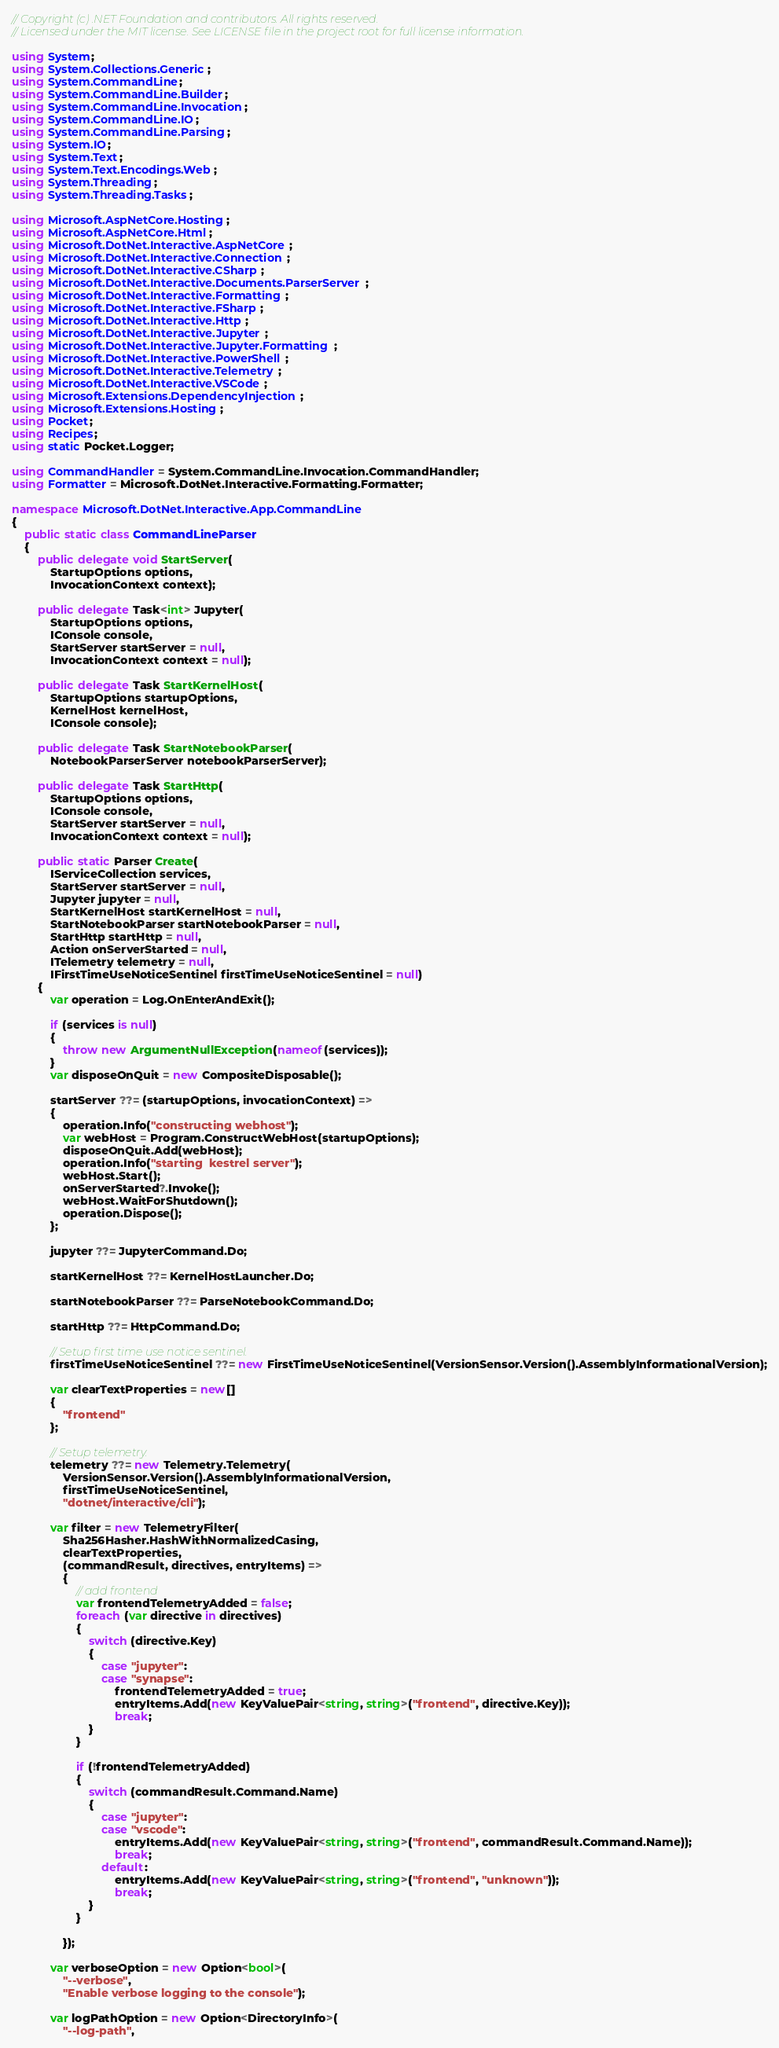Convert code to text. <code><loc_0><loc_0><loc_500><loc_500><_C#_>// Copyright (c) .NET Foundation and contributors. All rights reserved.
// Licensed under the MIT license. See LICENSE file in the project root for full license information.

using System;
using System.Collections.Generic;
using System.CommandLine;
using System.CommandLine.Builder;
using System.CommandLine.Invocation;
using System.CommandLine.IO;
using System.CommandLine.Parsing;
using System.IO;
using System.Text;
using System.Text.Encodings.Web;
using System.Threading;
using System.Threading.Tasks;

using Microsoft.AspNetCore.Hosting;
using Microsoft.AspNetCore.Html;
using Microsoft.DotNet.Interactive.AspNetCore;
using Microsoft.DotNet.Interactive.Connection;
using Microsoft.DotNet.Interactive.CSharp;
using Microsoft.DotNet.Interactive.Documents.ParserServer;
using Microsoft.DotNet.Interactive.Formatting;
using Microsoft.DotNet.Interactive.FSharp;
using Microsoft.DotNet.Interactive.Http;
using Microsoft.DotNet.Interactive.Jupyter;
using Microsoft.DotNet.Interactive.Jupyter.Formatting;
using Microsoft.DotNet.Interactive.PowerShell;
using Microsoft.DotNet.Interactive.Telemetry;
using Microsoft.DotNet.Interactive.VSCode;
using Microsoft.Extensions.DependencyInjection;
using Microsoft.Extensions.Hosting;
using Pocket;
using Recipes;
using static Pocket.Logger;

using CommandHandler = System.CommandLine.Invocation.CommandHandler;
using Formatter = Microsoft.DotNet.Interactive.Formatting.Formatter;

namespace Microsoft.DotNet.Interactive.App.CommandLine
{
    public static class CommandLineParser
    {
        public delegate void StartServer(
            StartupOptions options,
            InvocationContext context);

        public delegate Task<int> Jupyter(
            StartupOptions options,
            IConsole console,
            StartServer startServer = null,
            InvocationContext context = null);

        public delegate Task StartKernelHost(
            StartupOptions startupOptions,
            KernelHost kernelHost,
            IConsole console);

        public delegate Task StartNotebookParser(
            NotebookParserServer notebookParserServer);

        public delegate Task StartHttp(
            StartupOptions options,
            IConsole console,
            StartServer startServer = null,
            InvocationContext context = null);

        public static Parser Create(
            IServiceCollection services,
            StartServer startServer = null,
            Jupyter jupyter = null,
            StartKernelHost startKernelHost = null,
            StartNotebookParser startNotebookParser = null,
            StartHttp startHttp = null,
            Action onServerStarted = null,
            ITelemetry telemetry = null,
            IFirstTimeUseNoticeSentinel firstTimeUseNoticeSentinel = null)
        {
            var operation = Log.OnEnterAndExit();

            if (services is null)
            {
                throw new ArgumentNullException(nameof(services));
            }
            var disposeOnQuit = new CompositeDisposable();

            startServer ??= (startupOptions, invocationContext) =>
            {
                operation.Info("constructing webhost");
                var webHost = Program.ConstructWebHost(startupOptions);
                disposeOnQuit.Add(webHost);
                operation.Info("starting  kestrel server");
                webHost.Start();
                onServerStarted?.Invoke();
                webHost.WaitForShutdown();
                operation.Dispose();
            };

            jupyter ??= JupyterCommand.Do;

            startKernelHost ??= KernelHostLauncher.Do;
            
            startNotebookParser ??= ParseNotebookCommand.Do;

            startHttp ??= HttpCommand.Do;

            // Setup first time use notice sentinel.
            firstTimeUseNoticeSentinel ??= new FirstTimeUseNoticeSentinel(VersionSensor.Version().AssemblyInformationalVersion);

            var clearTextProperties = new[]
            {
                "frontend"
            };

            // Setup telemetry.
            telemetry ??= new Telemetry.Telemetry(
                VersionSensor.Version().AssemblyInformationalVersion,
                firstTimeUseNoticeSentinel,
                "dotnet/interactive/cli");

            var filter = new TelemetryFilter(
                Sha256Hasher.HashWithNormalizedCasing,
                clearTextProperties,
                (commandResult, directives, entryItems) =>
                {
                    // add frontend
                    var frontendTelemetryAdded = false;
                    foreach (var directive in directives)
                    {
                        switch (directive.Key)
                        {
                            case "jupyter":
                            case "synapse":
                                frontendTelemetryAdded = true;
                                entryItems.Add(new KeyValuePair<string, string>("frontend", directive.Key));
                                break;
                        }
                    }

                    if (!frontendTelemetryAdded)
                    {
                        switch (commandResult.Command.Name)
                        {
                            case "jupyter":
                            case "vscode":
                                entryItems.Add(new KeyValuePair<string, string>("frontend", commandResult.Command.Name));
                                break;
                            default:
                                entryItems.Add(new KeyValuePair<string, string>("frontend", "unknown"));
                                break;
                        }
                    }

                });

            var verboseOption = new Option<bool>(
                "--verbose",
                "Enable verbose logging to the console");

            var logPathOption = new Option<DirectoryInfo>(
                "--log-path",</code> 